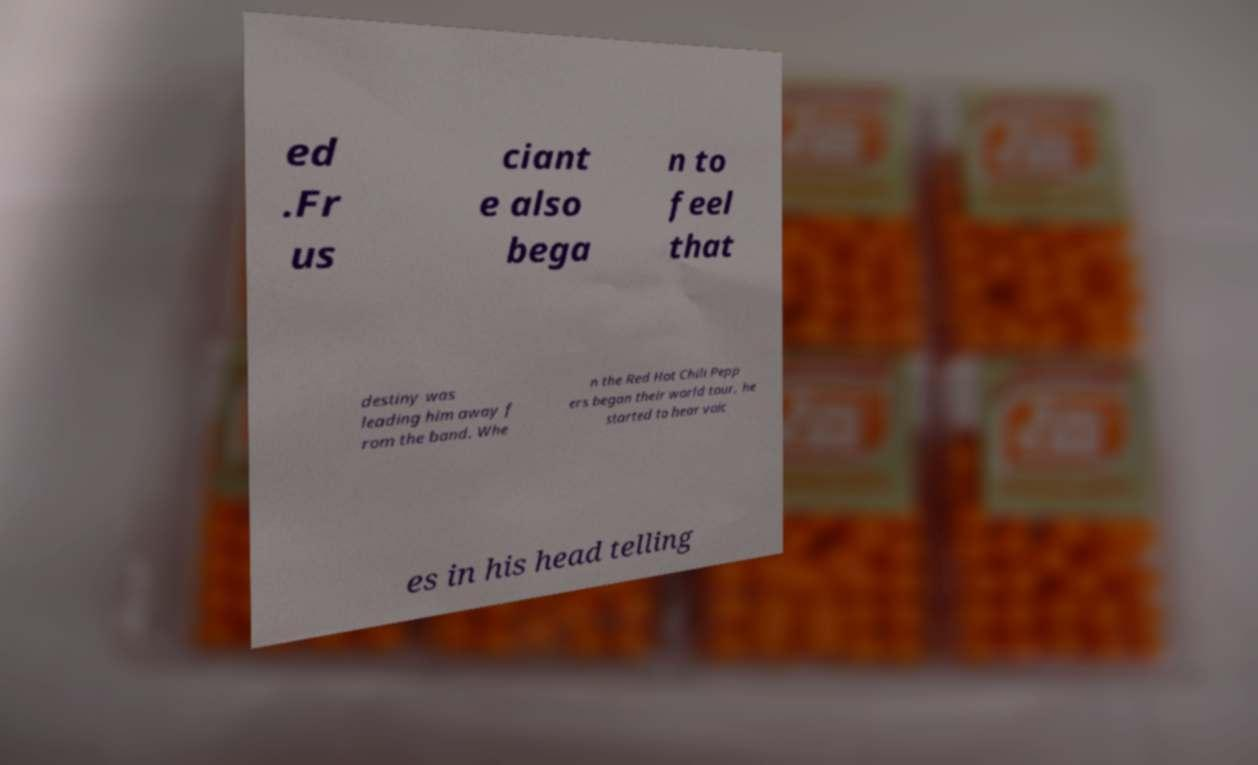There's text embedded in this image that I need extracted. Can you transcribe it verbatim? ed .Fr us ciant e also bega n to feel that destiny was leading him away f rom the band. Whe n the Red Hot Chili Pepp ers began their world tour, he started to hear voic es in his head telling 